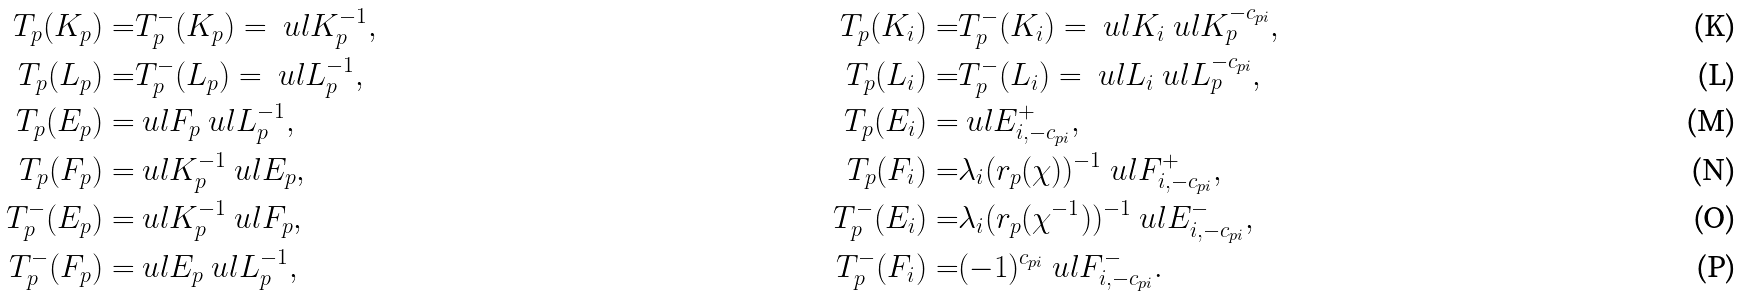<formula> <loc_0><loc_0><loc_500><loc_500>\L T _ { p } ( K _ { p } ) = & \L T _ { p } ^ { - } ( K _ { p } ) = \ u l K _ { p } ^ { - 1 } , & \L T _ { p } ( K _ { i } ) = & \L T _ { p } ^ { - } ( K _ { i } ) = \ u l K _ { i } \ u l K _ { p } ^ { - c _ { p i } } , \\ \L T _ { p } ( L _ { p } ) = & \L T _ { p } ^ { - } ( L _ { p } ) = \ u l L _ { p } ^ { - 1 } , & \L T _ { p } ( L _ { i } ) = & \L T _ { p } ^ { - } ( L _ { i } ) = \ u l L _ { i } \ u l L _ { p } ^ { - c _ { p i } } , \\ \L T _ { p } ( E _ { p } ) = & \ u l F _ { p } \ u l L _ { p } ^ { - 1 } , & \L T _ { p } ( E _ { i } ) = & \ u l E ^ { + } _ { i , - c _ { p i } } , \\ \L T _ { p } ( F _ { p } ) = & \ u l K _ { p } ^ { - 1 } \ u l E _ { p } , & \L T _ { p } ( F _ { i } ) = & \lambda _ { i } ( r _ { p } ( \chi ) ) ^ { - 1 } \ u l F ^ { + } _ { i , - c _ { p i } } , \\ \L T _ { p } ^ { - } ( E _ { p } ) = & \ u l K _ { p } ^ { - 1 } \ u l F _ { p } , & \L T _ { p } ^ { - } ( E _ { i } ) = & \lambda _ { i } ( r _ { p } ( \chi ^ { - 1 } ) ) ^ { - 1 } \ u l E ^ { - } _ { i , - c _ { p i } } , \\ \L T _ { p } ^ { - } ( F _ { p } ) = & \ u l E _ { p } \ u l L _ { p } ^ { - 1 } , & \L T _ { p } ^ { - } ( F _ { i } ) = & ( - 1 ) ^ { c _ { p i } } \ u l F ^ { - } _ { i , - c _ { p i } } .</formula> 